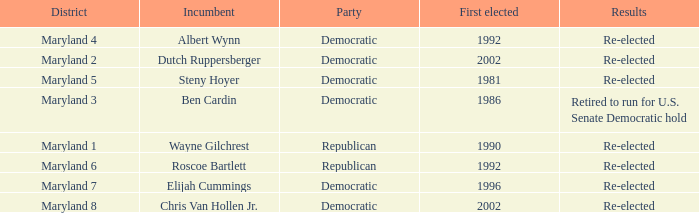What are the results of the incumbent who was first elected in 1996? Re-elected. 